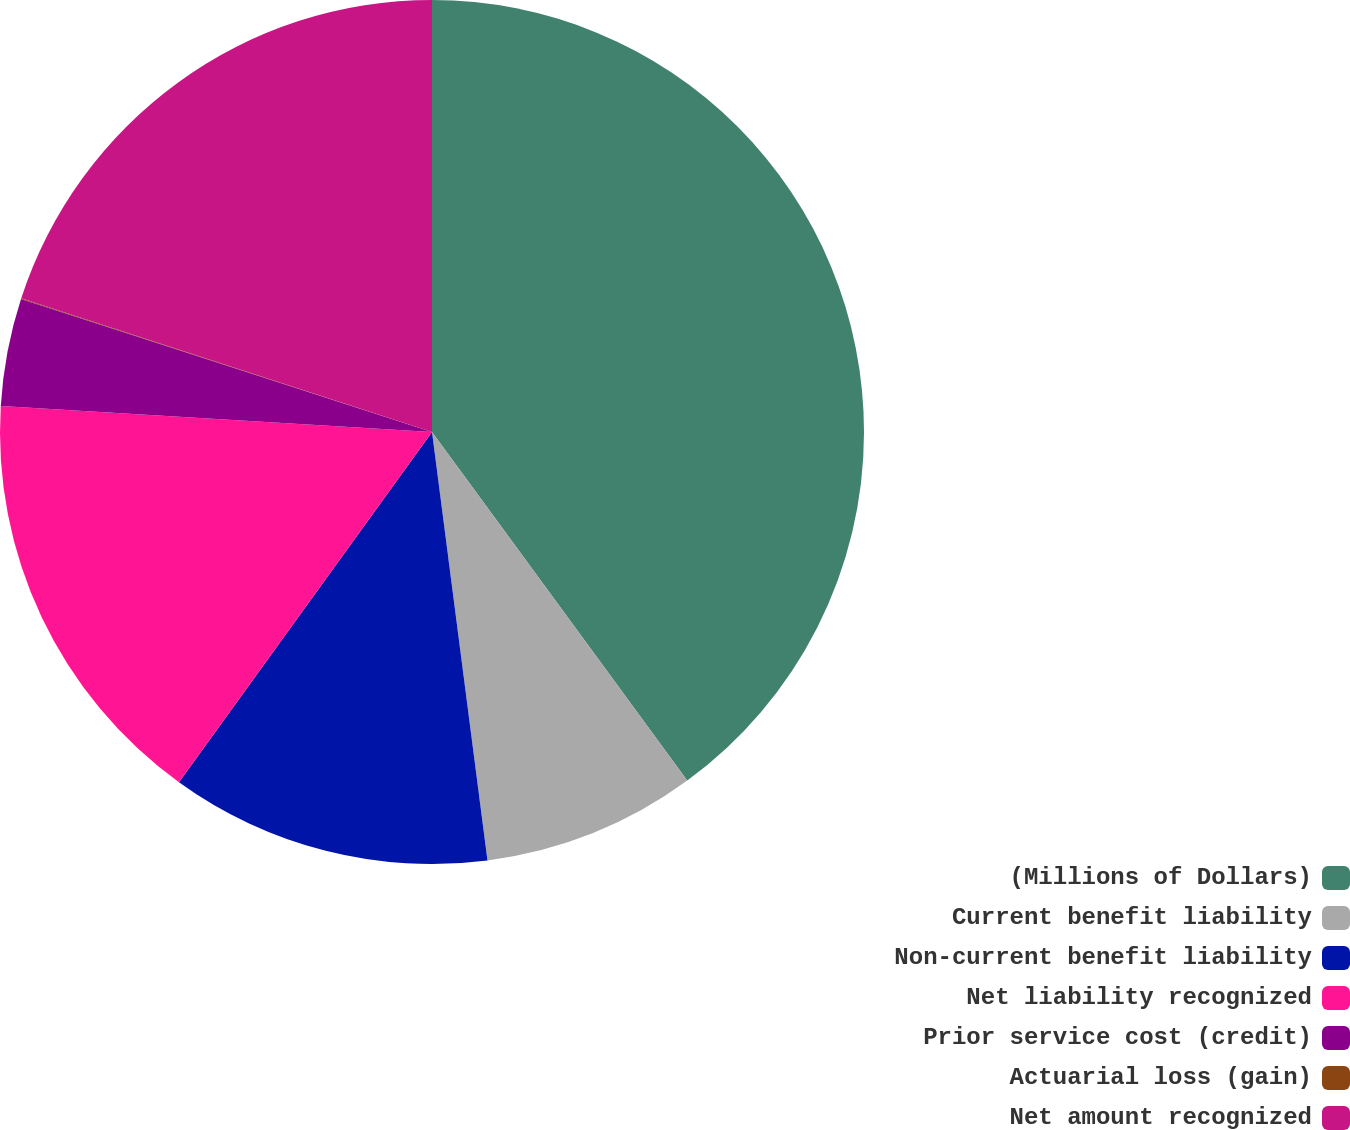Convert chart to OTSL. <chart><loc_0><loc_0><loc_500><loc_500><pie_chart><fcel>(Millions of Dollars)<fcel>Current benefit liability<fcel>Non-current benefit liability<fcel>Net liability recognized<fcel>Prior service cost (credit)<fcel>Actuarial loss (gain)<fcel>Net amount recognized<nl><fcel>39.94%<fcel>8.01%<fcel>12.01%<fcel>16.0%<fcel>4.02%<fcel>0.03%<fcel>19.99%<nl></chart> 